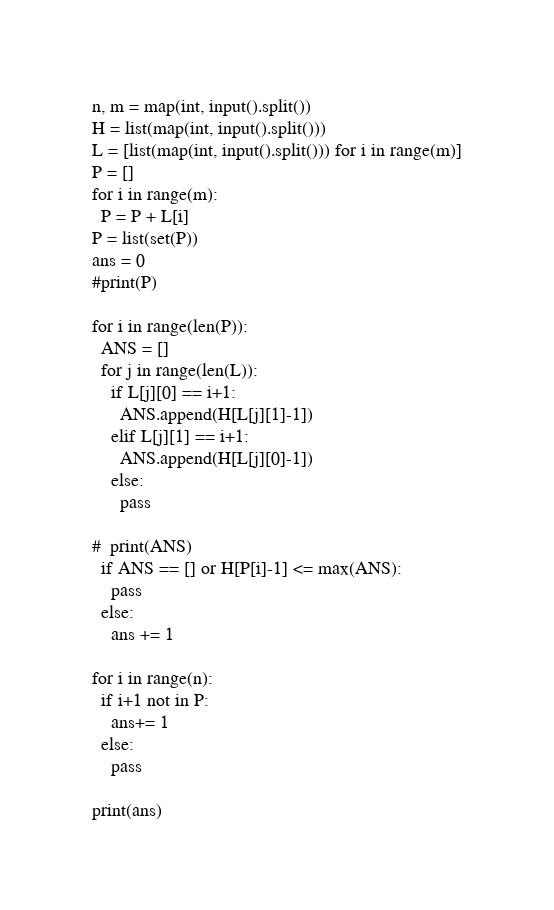<code> <loc_0><loc_0><loc_500><loc_500><_Python_>n, m = map(int, input().split())
H = list(map(int, input().split()))
L = [list(map(int, input().split())) for i in range(m)]
P = []
for i in range(m):
  P = P + L[i]
P = list(set(P))
ans = 0
#print(P)

for i in range(len(P)):
  ANS = []
  for j in range(len(L)):
    if L[j][0] == i+1:
      ANS.append(H[L[j][1]-1])
    elif L[j][1] == i+1:
      ANS.append(H[L[j][0]-1])
    else:
      pass
    
#  print(ANS) 
  if ANS == [] or H[P[i]-1] <= max(ANS):
    pass
  else:
    ans += 1
    
for i in range(n):
  if i+1 not in P:
    ans+= 1
  else:
    pass
    
print(ans)</code> 